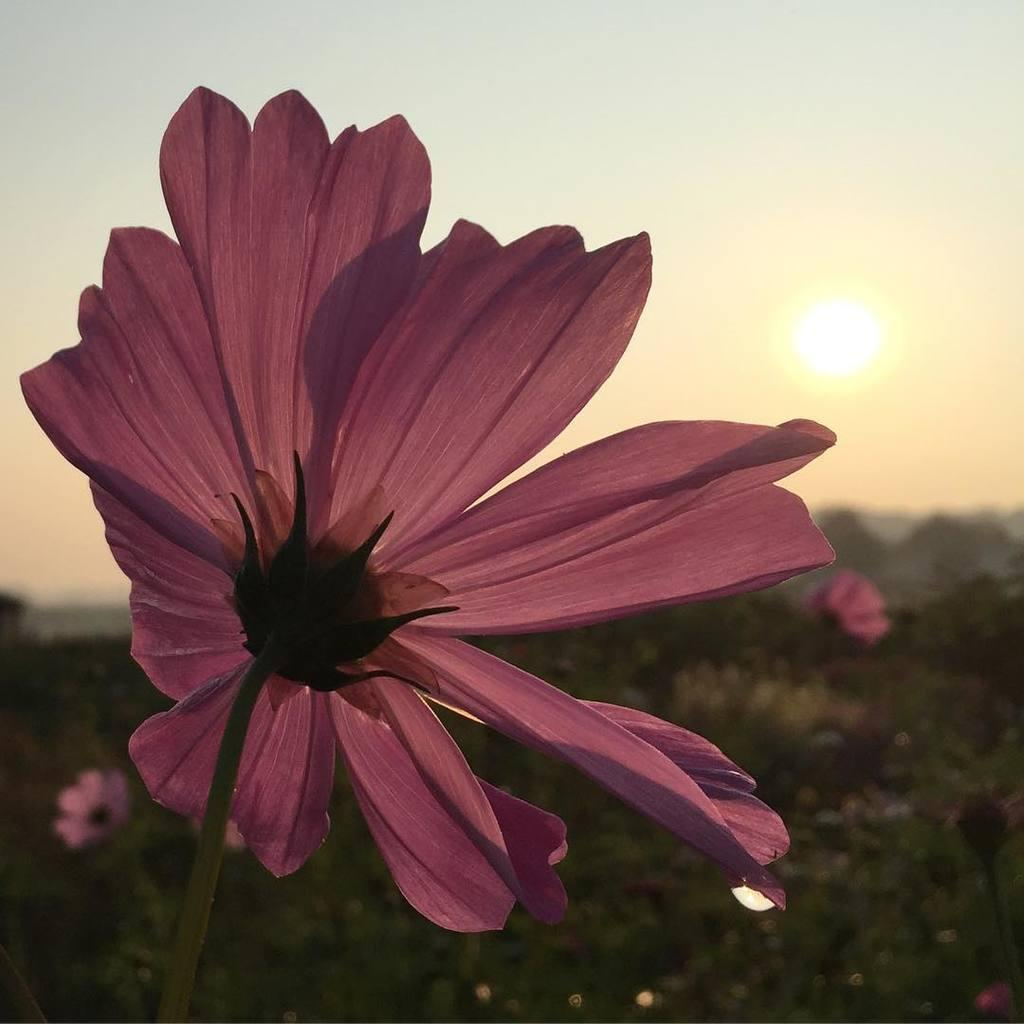What type of vegetation can be seen in the image? There are flowers, plants, and trees in the image. What is visible in the background of the image? Mountains, the sunset, and the sky are visible in the background of the image. What type of dirt can be seen on the pump in the image? There is no pump present in the image, so it is not possible to determine the type of dirt on it. 